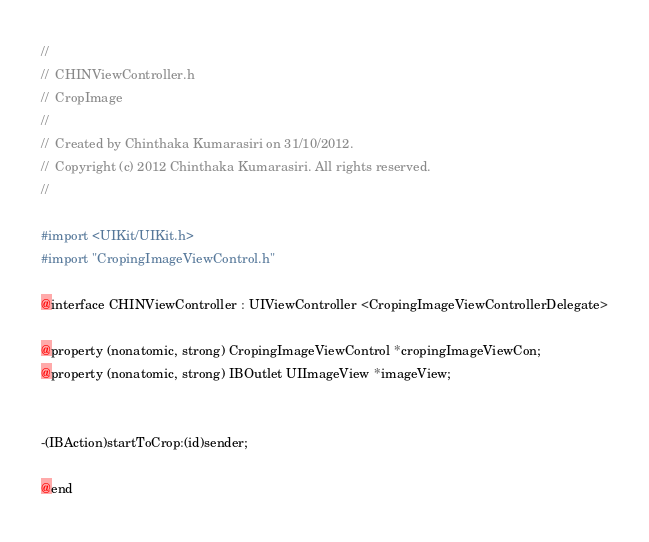<code> <loc_0><loc_0><loc_500><loc_500><_C_>//
//  CHINViewController.h
//  CropImage
//
//  Created by Chinthaka Kumarasiri on 31/10/2012.
//  Copyright (c) 2012 Chinthaka Kumarasiri. All rights reserved.
//

#import <UIKit/UIKit.h>
#import "CropingImageViewControl.h"

@interface CHINViewController : UIViewController <CropingImageViewControllerDelegate>

@property (nonatomic, strong) CropingImageViewControl *cropingImageViewCon;
@property (nonatomic, strong) IBOutlet UIImageView *imageView;


-(IBAction)startToCrop:(id)sender;

@end
</code> 